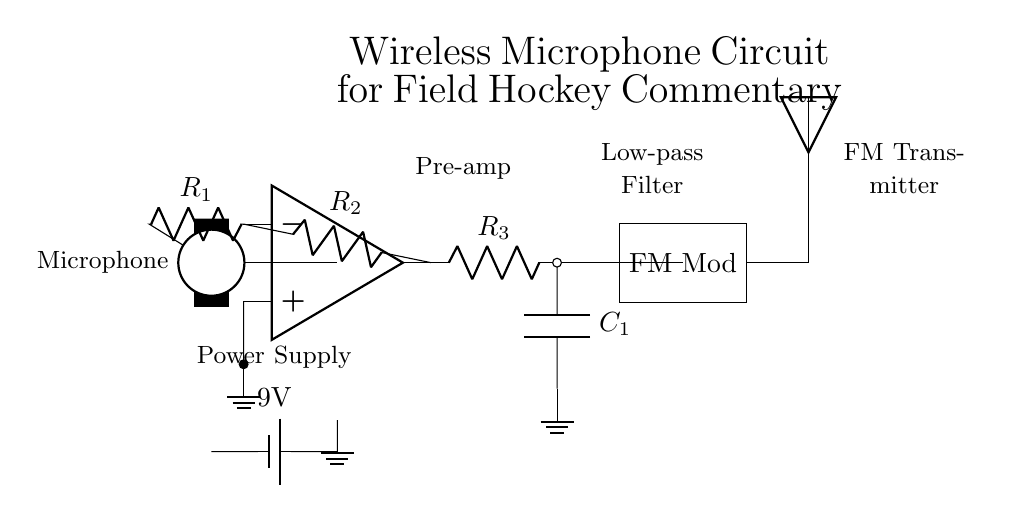What is the purpose of the microphone in this circuit? The microphone serves as the input transducer that converts sound waves into electrical signals for further processing in the circuit.
Answer: Input transducer What is the value of the battery in this circuit? The circuit diagram indicates the battery has a voltage of 9 volts, which powers the entire system.
Answer: 9 volts What does the op-amp do in this circuit? The op-amp acts as a preamplifier, amplifying the weak electrical signals from the microphone before they are processed further.
Answer: Preamplifier What type of filter is represented in this circuit? The low-pass filter (shown by R and C components) allows low-frequency signals to pass while attenuating high-frequency signals, essential for clean audio transmission in the context of field hockey commentary.
Answer: Low-pass filter What does the acronym FM stand for in this context? FM stands for Frequency Modulation, which is a method used in the circuit to encode the audio signal onto a carrier wave for wireless transmission.
Answer: Frequency Modulation How many resistors are present in this circuit? There are three resistors (R1, R2, R3) in the circuit that play different roles in signal processing and filtering.
Answer: Three What component is used for the wireless transmission of audio signals? The antenna is responsible for transmitting the audio signal wirelessly once it has been modulated.
Answer: Antenna 